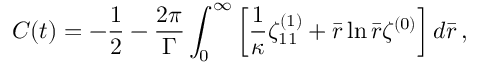Convert formula to latex. <formula><loc_0><loc_0><loc_500><loc_500>C ( t ) = - \frac { 1 } { 2 } - \frac { 2 \pi } { \Gamma } \int _ { 0 } ^ { \infty } \left [ \frac { 1 } { \kappa } \zeta _ { 1 1 } ^ { ( 1 ) } + \bar { r } \ln \bar { r } \zeta ^ { ( 0 ) } \right ] d \bar { r } \, ,</formula> 